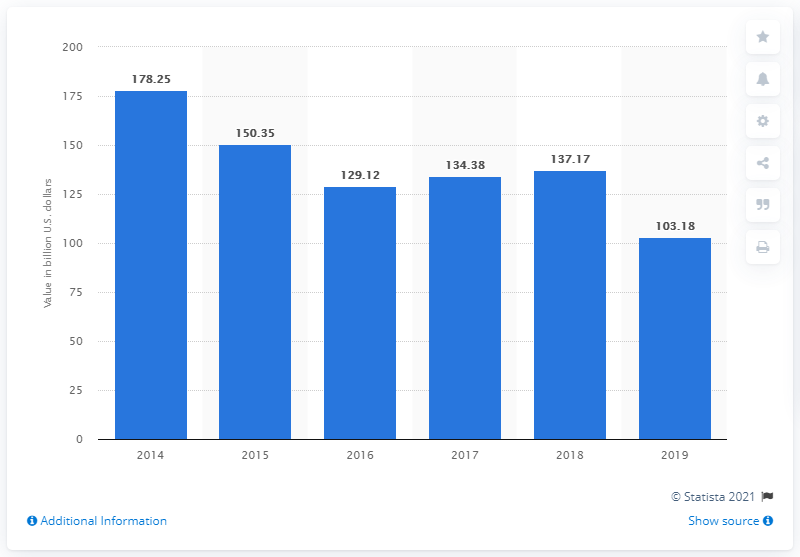Point out several critical features in this image. In 2019, the value of M&A deals in Canada reached 103.18 billion dollars. 